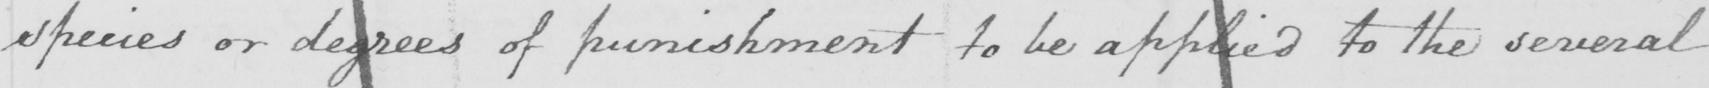What is written in this line of handwriting? species or degrees of punishment to be applied to the several 